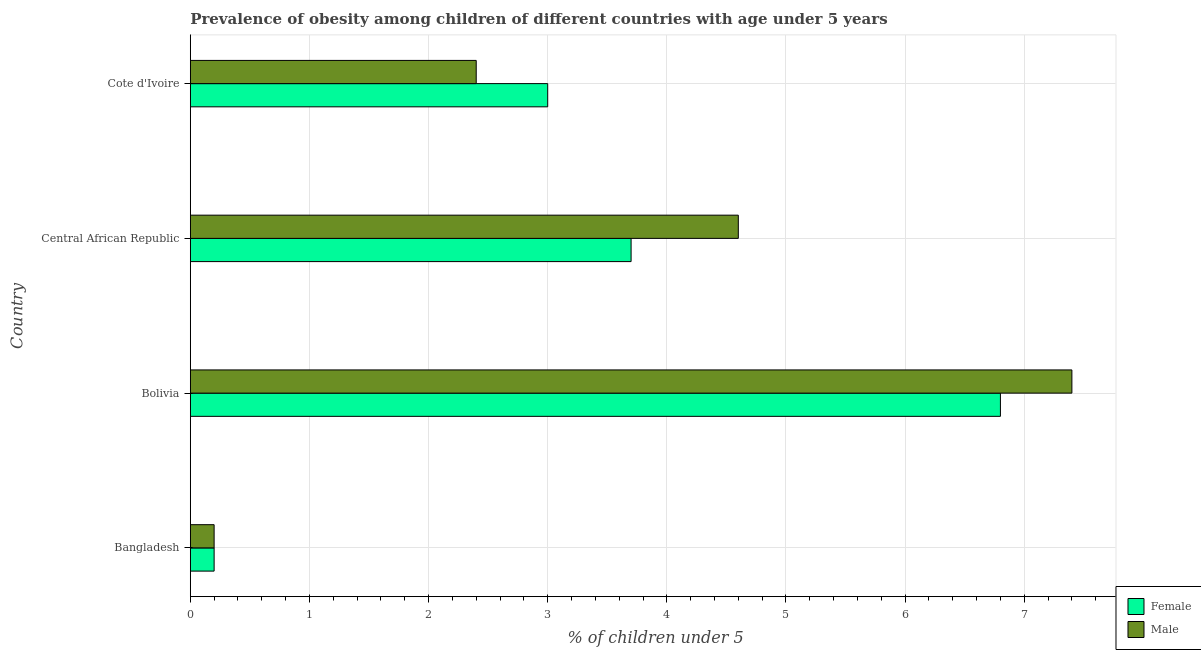Are the number of bars per tick equal to the number of legend labels?
Your response must be concise. Yes. How many bars are there on the 2nd tick from the bottom?
Your answer should be very brief. 2. What is the label of the 1st group of bars from the top?
Your answer should be very brief. Cote d'Ivoire. In how many cases, is the number of bars for a given country not equal to the number of legend labels?
Your response must be concise. 0. Across all countries, what is the maximum percentage of obese male children?
Your answer should be very brief. 7.4. Across all countries, what is the minimum percentage of obese male children?
Make the answer very short. 0.2. What is the total percentage of obese female children in the graph?
Give a very brief answer. 13.7. What is the difference between the percentage of obese female children in Bangladesh and that in Cote d'Ivoire?
Provide a succinct answer. -2.8. What is the difference between the percentage of obese male children in Bangladesh and the percentage of obese female children in Central African Republic?
Ensure brevity in your answer.  -3.5. What is the average percentage of obese female children per country?
Keep it short and to the point. 3.42. What is the ratio of the percentage of obese male children in Bangladesh to that in Central African Republic?
Give a very brief answer. 0.04. Is the percentage of obese male children in Central African Republic less than that in Cote d'Ivoire?
Provide a succinct answer. No. What is the difference between the highest and the lowest percentage of obese male children?
Ensure brevity in your answer.  7.2. In how many countries, is the percentage of obese male children greater than the average percentage of obese male children taken over all countries?
Give a very brief answer. 2. Is the sum of the percentage of obese female children in Bangladesh and Bolivia greater than the maximum percentage of obese male children across all countries?
Your response must be concise. No. What does the 1st bar from the bottom in Bolivia represents?
Make the answer very short. Female. Are all the bars in the graph horizontal?
Keep it short and to the point. Yes. How many countries are there in the graph?
Offer a very short reply. 4. Are the values on the major ticks of X-axis written in scientific E-notation?
Provide a short and direct response. No. Does the graph contain any zero values?
Your answer should be very brief. No. Does the graph contain grids?
Provide a succinct answer. Yes. How many legend labels are there?
Your answer should be very brief. 2. What is the title of the graph?
Your response must be concise. Prevalence of obesity among children of different countries with age under 5 years. Does "Measles" appear as one of the legend labels in the graph?
Offer a very short reply. No. What is the label or title of the X-axis?
Give a very brief answer.  % of children under 5. What is the  % of children under 5 of Female in Bangladesh?
Your answer should be very brief. 0.2. What is the  % of children under 5 of Male in Bangladesh?
Ensure brevity in your answer.  0.2. What is the  % of children under 5 in Female in Bolivia?
Your answer should be compact. 6.8. What is the  % of children under 5 in Male in Bolivia?
Offer a terse response. 7.4. What is the  % of children under 5 of Female in Central African Republic?
Ensure brevity in your answer.  3.7. What is the  % of children under 5 of Male in Central African Republic?
Give a very brief answer. 4.6. What is the  % of children under 5 of Male in Cote d'Ivoire?
Your response must be concise. 2.4. Across all countries, what is the maximum  % of children under 5 in Female?
Give a very brief answer. 6.8. Across all countries, what is the maximum  % of children under 5 in Male?
Offer a terse response. 7.4. Across all countries, what is the minimum  % of children under 5 in Female?
Provide a short and direct response. 0.2. Across all countries, what is the minimum  % of children under 5 in Male?
Make the answer very short. 0.2. What is the total  % of children under 5 of Female in the graph?
Offer a terse response. 13.7. What is the total  % of children under 5 of Male in the graph?
Ensure brevity in your answer.  14.6. What is the difference between the  % of children under 5 in Female in Bangladesh and that in Bolivia?
Provide a short and direct response. -6.6. What is the difference between the  % of children under 5 of Female in Bangladesh and that in Cote d'Ivoire?
Provide a succinct answer. -2.8. What is the difference between the  % of children under 5 in Female in Bolivia and that in Central African Republic?
Ensure brevity in your answer.  3.1. What is the difference between the  % of children under 5 in Male in Bolivia and that in Central African Republic?
Make the answer very short. 2.8. What is the difference between the  % of children under 5 in Female in Bolivia and that in Cote d'Ivoire?
Keep it short and to the point. 3.8. What is the difference between the  % of children under 5 in Female in Central African Republic and that in Cote d'Ivoire?
Offer a terse response. 0.7. What is the difference between the  % of children under 5 in Female in Bangladesh and the  % of children under 5 in Male in Central African Republic?
Your response must be concise. -4.4. What is the difference between the  % of children under 5 of Female in Bangladesh and the  % of children under 5 of Male in Cote d'Ivoire?
Provide a short and direct response. -2.2. What is the difference between the  % of children under 5 in Female in Bolivia and the  % of children under 5 in Male in Central African Republic?
Keep it short and to the point. 2.2. What is the difference between the  % of children under 5 in Female in Bolivia and the  % of children under 5 in Male in Cote d'Ivoire?
Your answer should be compact. 4.4. What is the difference between the  % of children under 5 in Female in Central African Republic and the  % of children under 5 in Male in Cote d'Ivoire?
Your response must be concise. 1.3. What is the average  % of children under 5 of Female per country?
Offer a very short reply. 3.42. What is the average  % of children under 5 in Male per country?
Provide a succinct answer. 3.65. What is the difference between the  % of children under 5 in Female and  % of children under 5 in Male in Cote d'Ivoire?
Provide a short and direct response. 0.6. What is the ratio of the  % of children under 5 in Female in Bangladesh to that in Bolivia?
Your answer should be very brief. 0.03. What is the ratio of the  % of children under 5 of Male in Bangladesh to that in Bolivia?
Offer a terse response. 0.03. What is the ratio of the  % of children under 5 of Female in Bangladesh to that in Central African Republic?
Ensure brevity in your answer.  0.05. What is the ratio of the  % of children under 5 of Male in Bangladesh to that in Central African Republic?
Offer a very short reply. 0.04. What is the ratio of the  % of children under 5 of Female in Bangladesh to that in Cote d'Ivoire?
Give a very brief answer. 0.07. What is the ratio of the  % of children under 5 in Male in Bangladesh to that in Cote d'Ivoire?
Provide a succinct answer. 0.08. What is the ratio of the  % of children under 5 of Female in Bolivia to that in Central African Republic?
Provide a short and direct response. 1.84. What is the ratio of the  % of children under 5 of Male in Bolivia to that in Central African Republic?
Keep it short and to the point. 1.61. What is the ratio of the  % of children under 5 in Female in Bolivia to that in Cote d'Ivoire?
Your response must be concise. 2.27. What is the ratio of the  % of children under 5 of Male in Bolivia to that in Cote d'Ivoire?
Make the answer very short. 3.08. What is the ratio of the  % of children under 5 in Female in Central African Republic to that in Cote d'Ivoire?
Offer a very short reply. 1.23. What is the ratio of the  % of children under 5 in Male in Central African Republic to that in Cote d'Ivoire?
Offer a terse response. 1.92. What is the difference between the highest and the lowest  % of children under 5 in Female?
Offer a terse response. 6.6. 